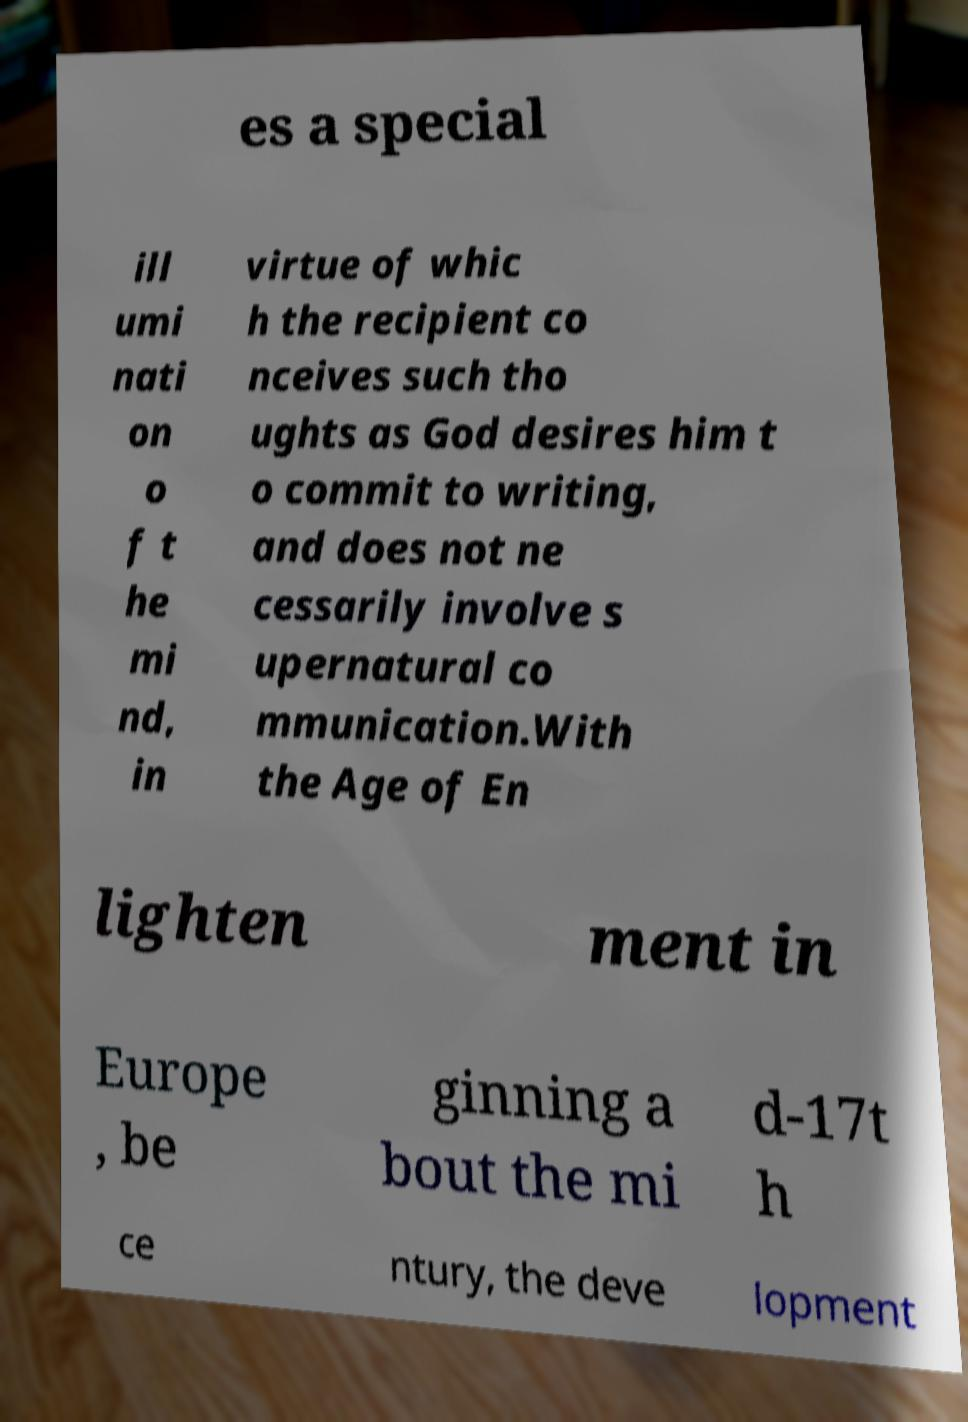I need the written content from this picture converted into text. Can you do that? es a special ill umi nati on o f t he mi nd, in virtue of whic h the recipient co nceives such tho ughts as God desires him t o commit to writing, and does not ne cessarily involve s upernatural co mmunication.With the Age of En lighten ment in Europe , be ginning a bout the mi d-17t h ce ntury, the deve lopment 